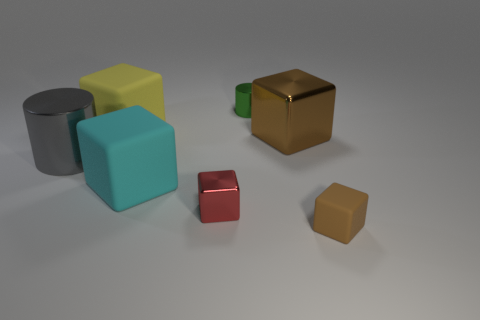Are any big cyan blocks visible?
Your answer should be compact. Yes. What number of small cylinders are the same color as the tiny rubber cube?
Your response must be concise. 0. Is the green object made of the same material as the small thing right of the tiny green metallic object?
Your answer should be very brief. No. Is the number of brown metal objects on the right side of the brown rubber thing greater than the number of gray things?
Your response must be concise. No. Do the tiny rubber cube and the metal block that is behind the cyan matte object have the same color?
Your answer should be very brief. Yes. Is the number of big cyan things in front of the small green metallic thing the same as the number of shiny things in front of the big metallic cylinder?
Offer a terse response. Yes. There is a cylinder in front of the tiny green metallic thing; what is its material?
Provide a short and direct response. Metal. What number of things are large objects that are left of the cyan cube or big blue cylinders?
Ensure brevity in your answer.  2. What number of other things are there of the same shape as the red metal object?
Your answer should be compact. 4. Do the brown thing to the left of the tiny brown rubber object and the red thing have the same shape?
Offer a terse response. Yes. 